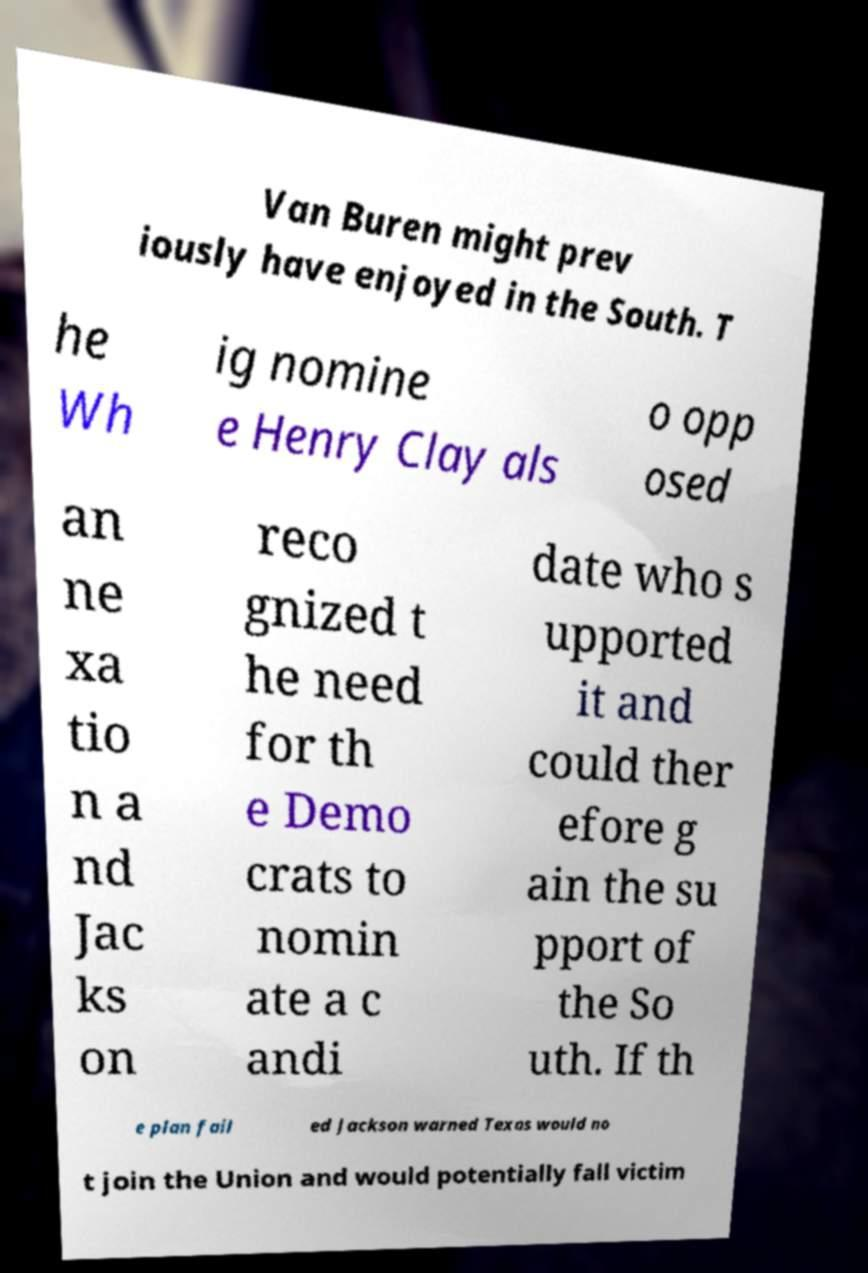Please read and relay the text visible in this image. What does it say? Van Buren might prev iously have enjoyed in the South. T he Wh ig nomine e Henry Clay als o opp osed an ne xa tio n a nd Jac ks on reco gnized t he need for th e Demo crats to nomin ate a c andi date who s upported it and could ther efore g ain the su pport of the So uth. If th e plan fail ed Jackson warned Texas would no t join the Union and would potentially fall victim 